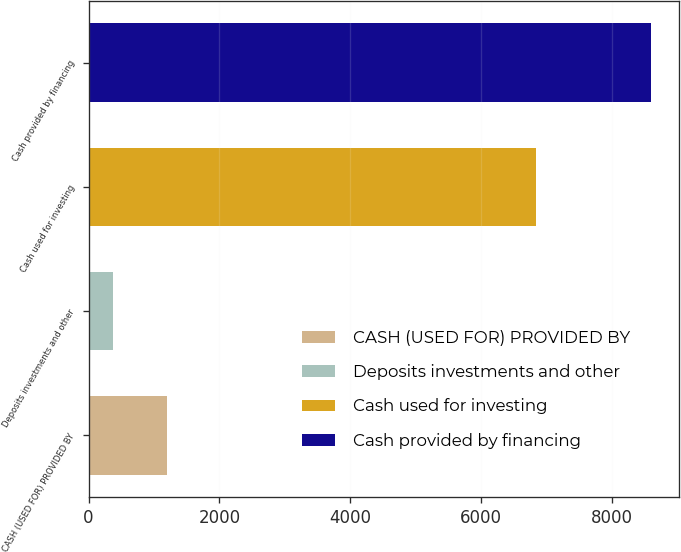Convert chart to OTSL. <chart><loc_0><loc_0><loc_500><loc_500><bar_chart><fcel>CASH (USED FOR) PROVIDED BY<fcel>Deposits investments and other<fcel>Cash used for investing<fcel>Cash provided by financing<nl><fcel>1194<fcel>372<fcel>6838<fcel>8592<nl></chart> 